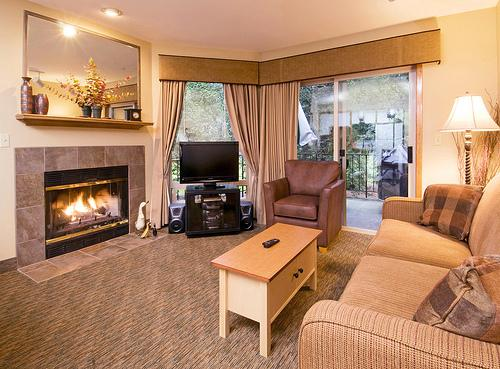Question: what color are the curtains?
Choices:
A. Brown.
B. Red.
C. Blue.
D. Pink.
Answer with the letter. Answer: D Question: what is reflecting from the mirror?
Choices:
A. Eyes.
B. The fire.
C. The light.
D. Sunshine.
Answer with the letter. Answer: C Question: what animals are to the right of the fireplace?
Choices:
A. Crows.
B. Sparrows.
C. Blue jays.
D. Ducks.
Answer with the letter. Answer: D Question: what shape is the top of the table?
Choices:
A. Rectangle.
B. Square.
C. Circle.
D. Triangle.
Answer with the letter. Answer: A Question: where is the couch?
Choices:
A. To the left.
B. In front of the chair.
C. To the right.
D. Behind the chair.
Answer with the letter. Answer: C 